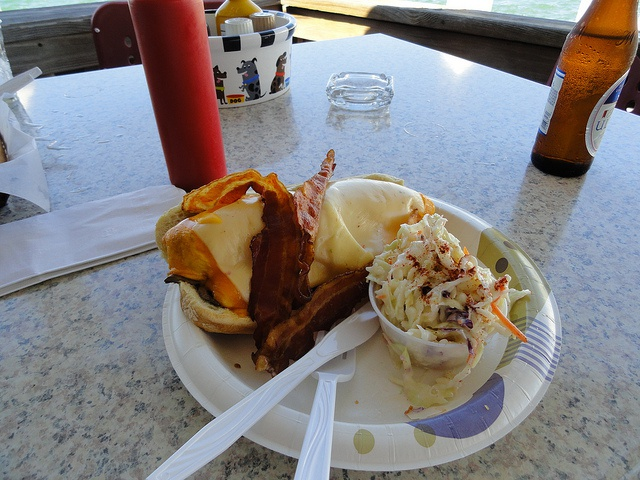Describe the objects in this image and their specific colors. I can see dining table in darkgray, gray, and lightblue tones, bowl in lightblue, darkgray, and gray tones, sandwich in lightblue, black, tan, olive, and maroon tones, bottle in lightblue, maroon, brown, black, and darkgray tones, and knife in lightblue, darkgray, and gray tones in this image. 